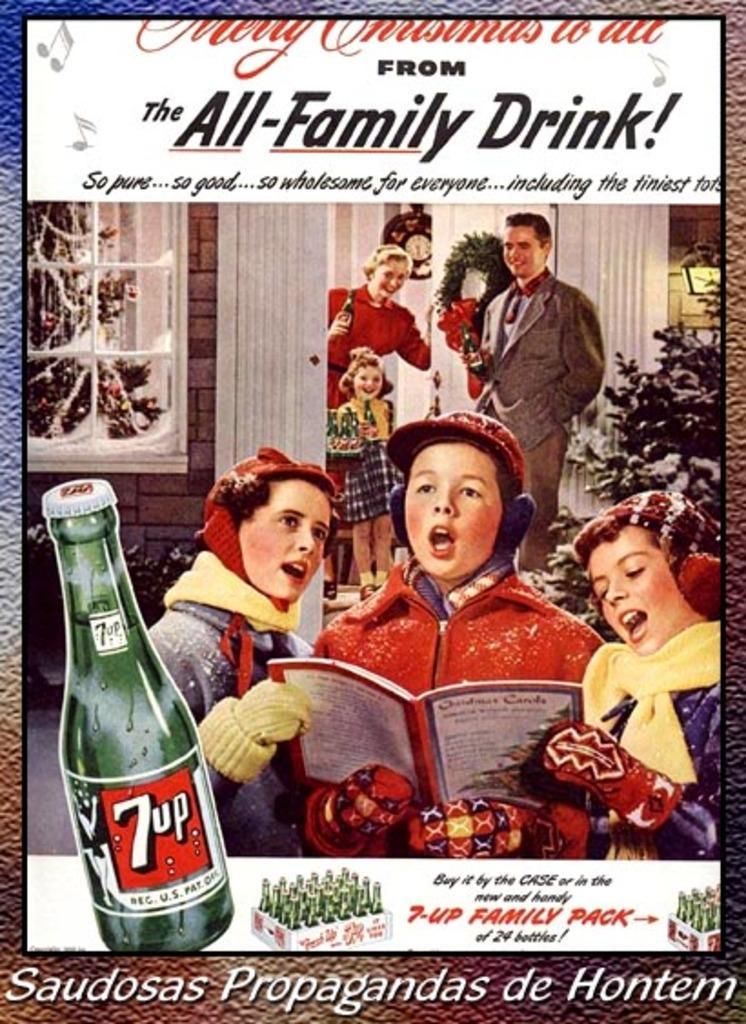How would you summarize this image in a sentence or two? In the center of the image there is a poster in which there are depictions of persons and some text. 